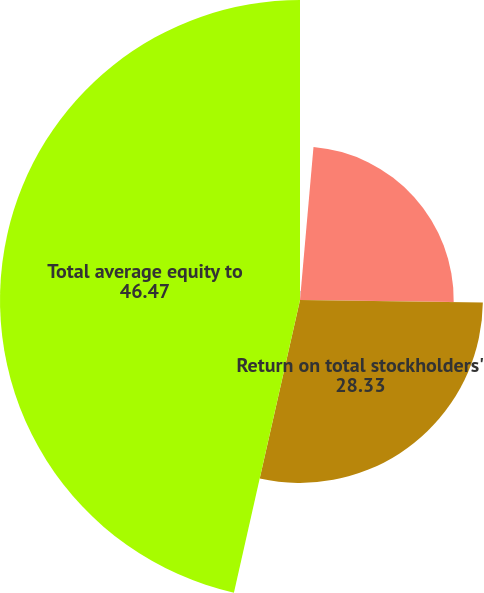Convert chart to OTSL. <chart><loc_0><loc_0><loc_500><loc_500><pie_chart><fcel>Net income to average assets<fcel>Return on common stockholders'<fcel>Return on total stockholders'<fcel>Total average equity to<nl><fcel>1.4%<fcel>23.81%<fcel>28.33%<fcel>46.47%<nl></chart> 